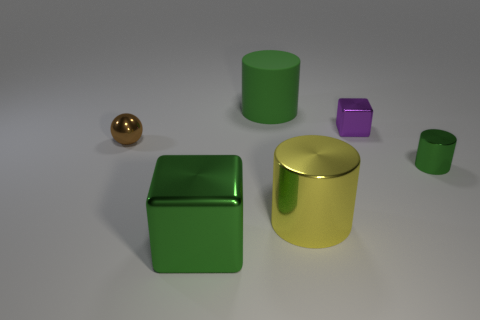Are there any other things of the same color as the large block?
Your answer should be very brief. Yes. There is a big green object that is made of the same material as the yellow cylinder; what shape is it?
Make the answer very short. Cube. There is a tiny metallic thing on the left side of the cube in front of the small shiny thing that is behind the brown thing; what is its color?
Offer a very short reply. Brown. Is the number of large shiny cylinders behind the tiny purple block the same as the number of yellow metal cylinders?
Ensure brevity in your answer.  No. Are there any other things that have the same material as the big green cylinder?
Your response must be concise. No. Does the tiny cylinder have the same color as the metal block that is in front of the tiny cylinder?
Keep it short and to the point. Yes. There is a yellow metallic cylinder in front of the metallic cube right of the green rubber thing; are there any rubber cylinders to the left of it?
Your answer should be compact. Yes. Are there fewer tiny things in front of the small green metallic thing than large green rubber cylinders?
Your answer should be very brief. Yes. How many other things are there of the same shape as the yellow object?
Give a very brief answer. 2. How many things are either small metal spheres that are left of the green metallic cube or tiny shiny objects on the left side of the yellow metal cylinder?
Offer a very short reply. 1. 